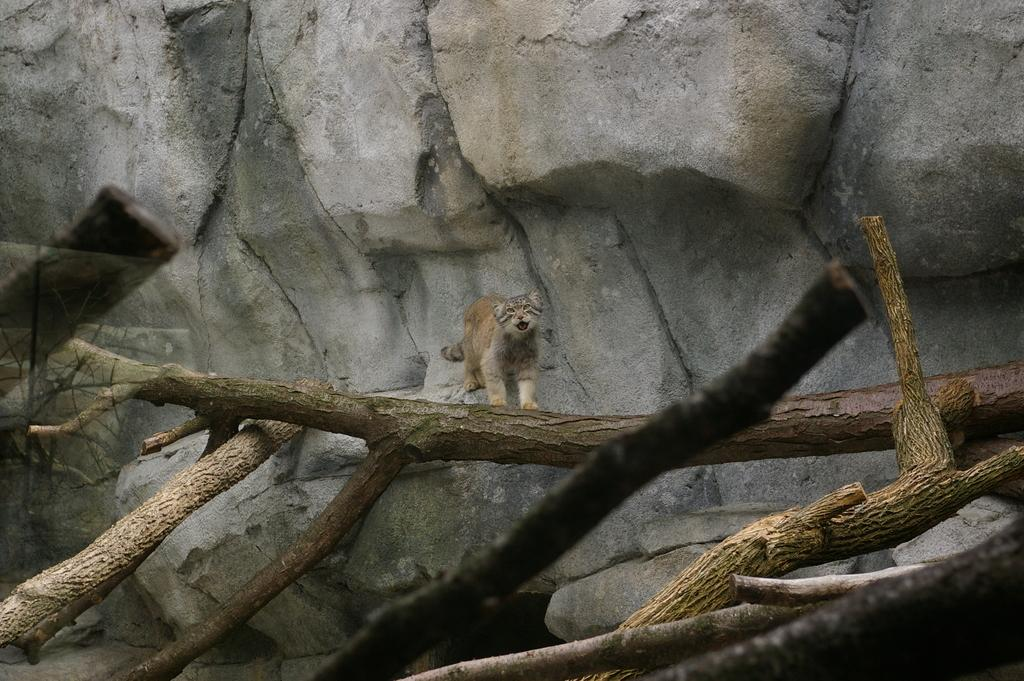What animal is near a rock in the image? There is a cat near a rock in the image. What type of vegetation can be seen in the image? There are dried tree stems in the image. What can be seen in the background of the image? There are rocks visible in the background of the image. What type of record is the cat holding in the image? There is no record present in the image; it features a cat near a rock and dried tree stems. 